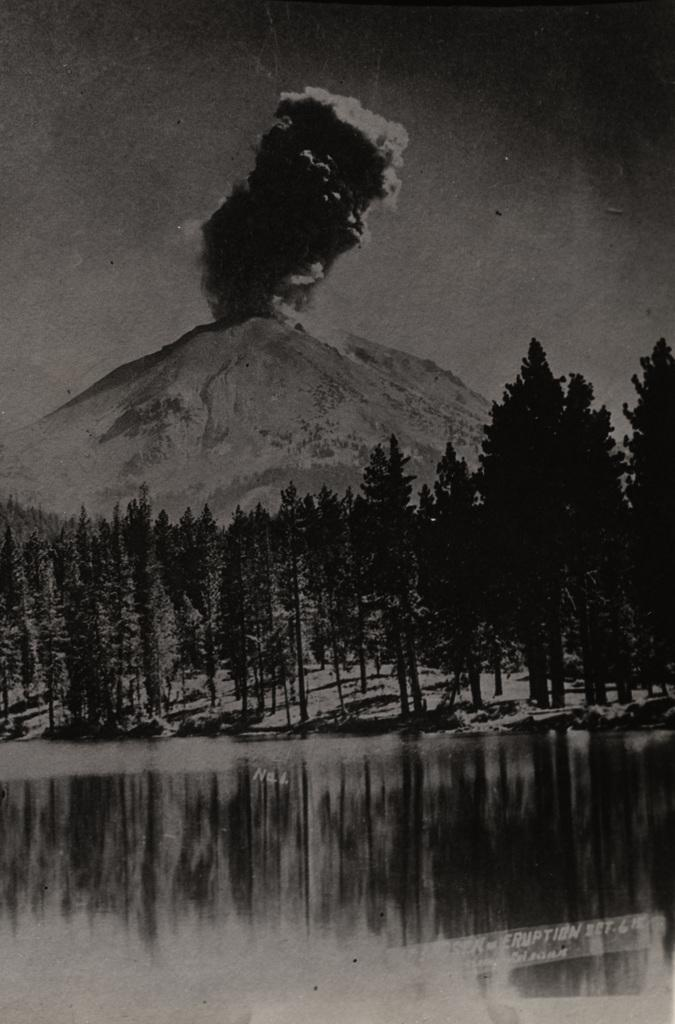What is the color scheme of the image? The image is black and white. What can be seen at the bottom of the image? There is a reflection of trees at the bottom of the image. How many trees are visible in the image? There are many trees visible in the image. What is present in the background of the image? There is a volcano hill with smoke in the background. Where are the dolls playing with a drum in the image? There are no dolls or drums present in the image. What type of house can be seen in the image? There is no house visible in the image. 